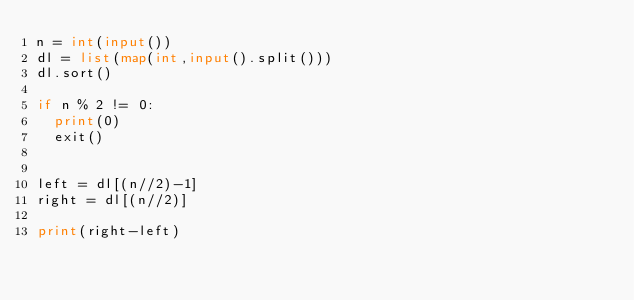Convert code to text. <code><loc_0><loc_0><loc_500><loc_500><_Python_>n = int(input())
dl = list(map(int,input().split()))
dl.sort()

if n % 2 != 0:
  print(0)
  exit()

  
left = dl[(n//2)-1]
right = dl[(n//2)]

print(right-left)
</code> 